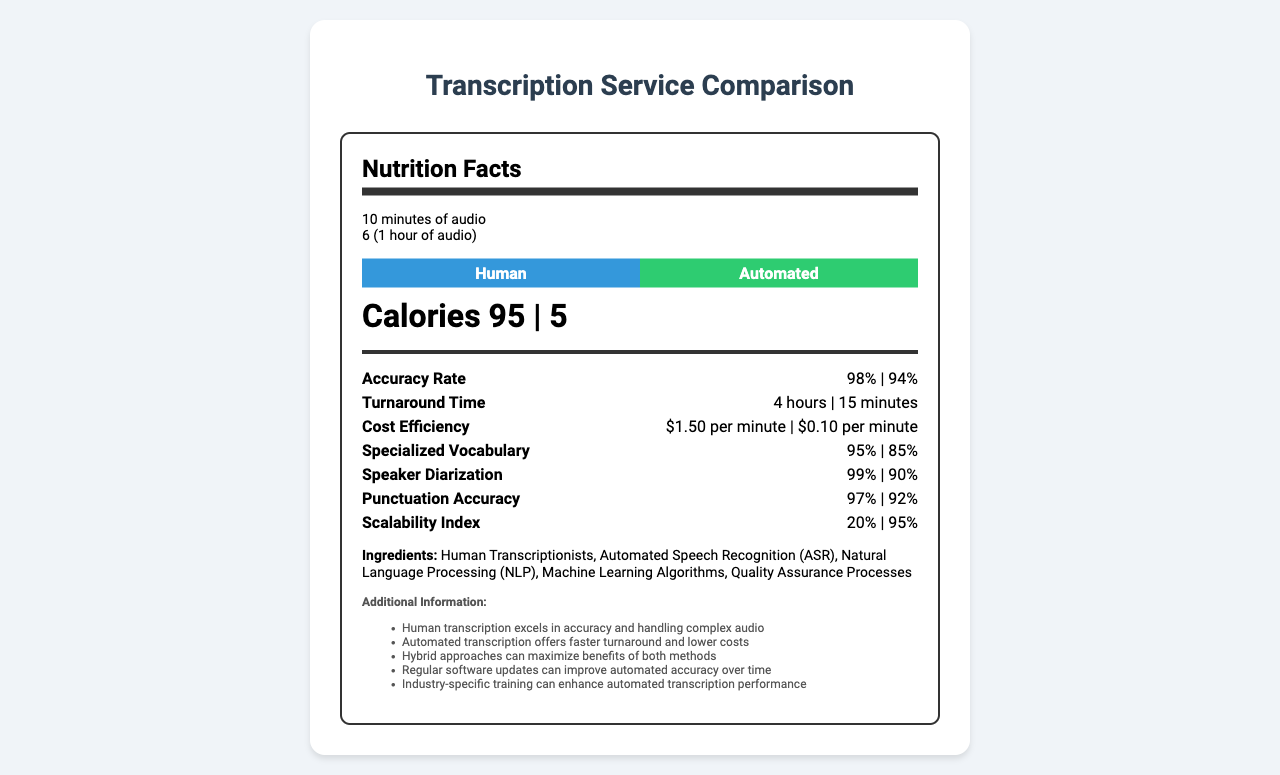What is the serving size for the transcription services comparison? The serving size is clearly stated in the document as "10 minutes of audio".
Answer: 10 minutes of audio What is the turnaround time for automated transcription? The turnaround time for automated transcription is listed as "15 minutes" in the document.
Answer: 15 minutes How accurate is human transcription compared to automated transcription? The accuracy rate for human transcription is 98%, while for automated transcription it is 94%.
Answer: 98% vs. 94% What is the cost efficiency for human transcription per minute? The cost efficiency for human transcription is noted as $1.50 per minute.
Answer: $1.50 per minute List the ingredients mentioned in the document. The ingredients listed in the document are Human Transcriptionists, Automated Speech Recognition (ASR), Natural Language Processing (NLP), Machine Learning Algorithms, and Quality Assurance Processes.
Answer: Human Transcriptionists, Automated Speech Recognition (ASR), Natural Language Processing (NLP), Machine Learning Algorithms, Quality Assurance Processes How does the scalability index compare between human and automated transcription? A. Human: 20%, Automated: 50% B. Human: 50%, Automated: 75% C. Human: 20%, Automated: 95% D. Human: 10%, Automated: 90% The document lists the scalability index for human transcription as 20% and for automated transcription as 95%.
Answer: C. Human: 20%, Automated: 95% Which transcription method has better speaker diarization accuracy? I. Human II. Automated The speaker diarization accuracy is 99% for human transcription and 90% for automated transcription, making the human method more accurate.
Answer: I. Human Is automated transcription more cost-efficient than human transcription? The cost efficiency for automated transcription is $0.10 per minute, which is significantly lower than $1.50 per minute for human transcription.
Answer: Yes Which transcription method has a quicker turnaround time? The turnaround time for automated transcription is 15 minutes, compared to 4 hours for human transcription.
Answer: Automated Summarize the main idea of the document. The document presents a detailed comparison of human and automated transcription services, showcasing their performance in multiple categories to help readers understand the advantages and limitations of each method.
Answer: The document compares human and automated transcription services across various metrics such as accuracy rate, turnaround time, cost efficiency, specialized vocabulary, speaker diarization, punctuation accuracy, and scalability. It highlights the strengths and weaknesses of both methods, suggesting potential benefits of hybrid approaches and improvements over time for automated transcription. What are the "Calories" referring to in the context of this document? The document does not provide sufficient context to determine what the "Calories" represent in terms of transcription services.
Answer: Cannot be determined What are the daily values (%) influenced by for each metric like accuracy rate, turnaround time, etc.? The document lists daily values for each metric but does not explain the basis or calculation method for these percentages.
Answer: Cannot be determined 